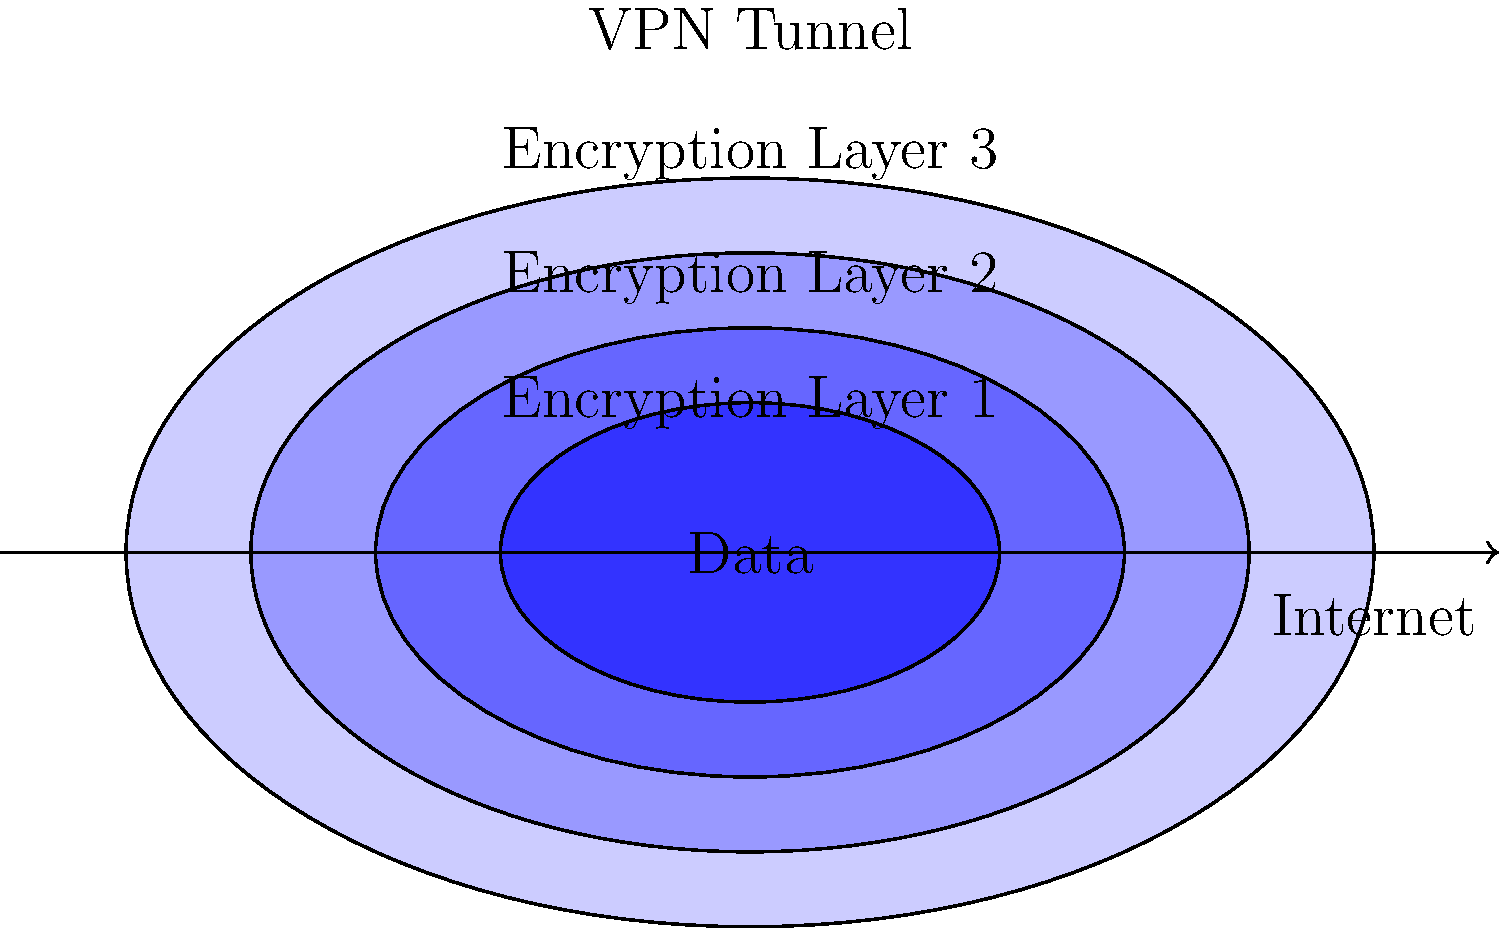In the given VPN connection diagram, how many layers of encryption are typically applied to the data before it enters the VPN tunnel? To answer this question, let's analyze the diagram step-by-step:

1. The innermost layer represents the raw data that needs to be transmitted.

2. Moving outward, we can see three distinct layers surrounding the data, each represented by a different shade of blue:
   a) The first layer directly encapsulating the data
   b) A second layer surrounding the first
   c) A third layer encompassing both previous layers

3. These three layers represent different levels of encryption applied to the data:
   - Encryption Layer 1: Usually applies to the payload (e.g., HTTPS for web traffic)
   - Encryption Layer 2: Often corresponds to the VPN protocol's encryption (e.g., OpenVPN, IPSec)
   - Encryption Layer 3: Typically represents an additional layer of encryption or obfuscation (e.g., multi-hop VPN, or additional encryption for enhanced security)

4. The outermost layer, labeled "VPN Tunnel," represents the secure channel through which the encrypted data travels over the internet.

5. It's important to note that while some VPN implementations might use fewer layers, this diagram illustrates a robust, multi-layered encryption approach often favored in high-security environments.

Therefore, based on the diagram, there are typically 3 layers of encryption applied to the data before it enters the VPN tunnel.
Answer: 3 layers 